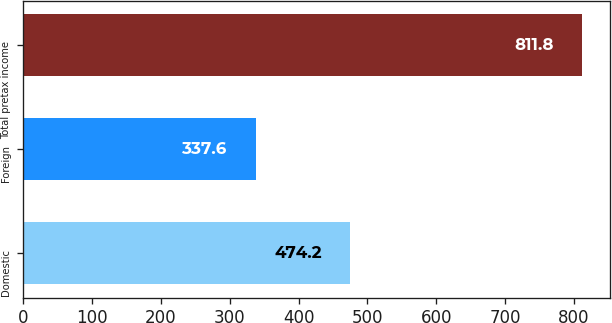Convert chart to OTSL. <chart><loc_0><loc_0><loc_500><loc_500><bar_chart><fcel>Domestic<fcel>Foreign<fcel>Total pretax income<nl><fcel>474.2<fcel>337.6<fcel>811.8<nl></chart> 